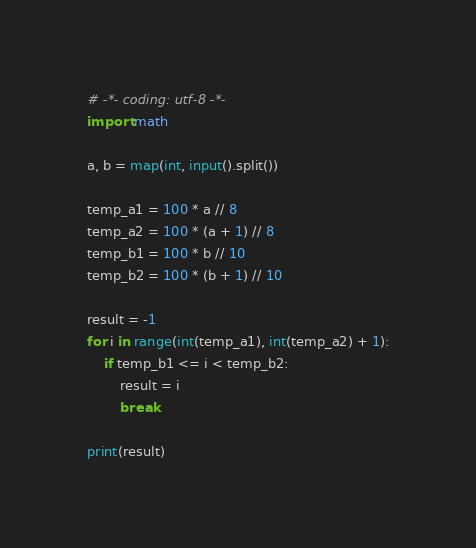<code> <loc_0><loc_0><loc_500><loc_500><_Python_># -*- coding: utf-8 -*-
import math

a, b = map(int, input().split())

temp_a1 = 100 * a // 8
temp_a2 = 100 * (a + 1) // 8
temp_b1 = 100 * b // 10
temp_b2 = 100 * (b + 1) // 10

result = -1
for i in range(int(temp_a1), int(temp_a2) + 1):
    if temp_b1 <= i < temp_b2:
        result = i
        break

print(result)
</code> 